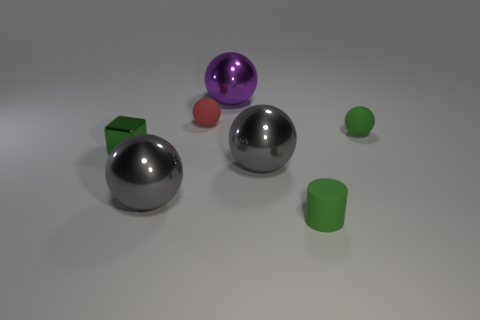Subtract 2 spheres. How many spheres are left? 3 Subtract all brown balls. Subtract all cyan cylinders. How many balls are left? 5 Add 3 small balls. How many objects exist? 10 Subtract all cylinders. How many objects are left? 6 Add 6 gray spheres. How many gray spheres are left? 8 Add 1 large purple shiny balls. How many large purple shiny balls exist? 2 Subtract 1 purple balls. How many objects are left? 6 Subtract all blue metal blocks. Subtract all big purple metallic spheres. How many objects are left? 6 